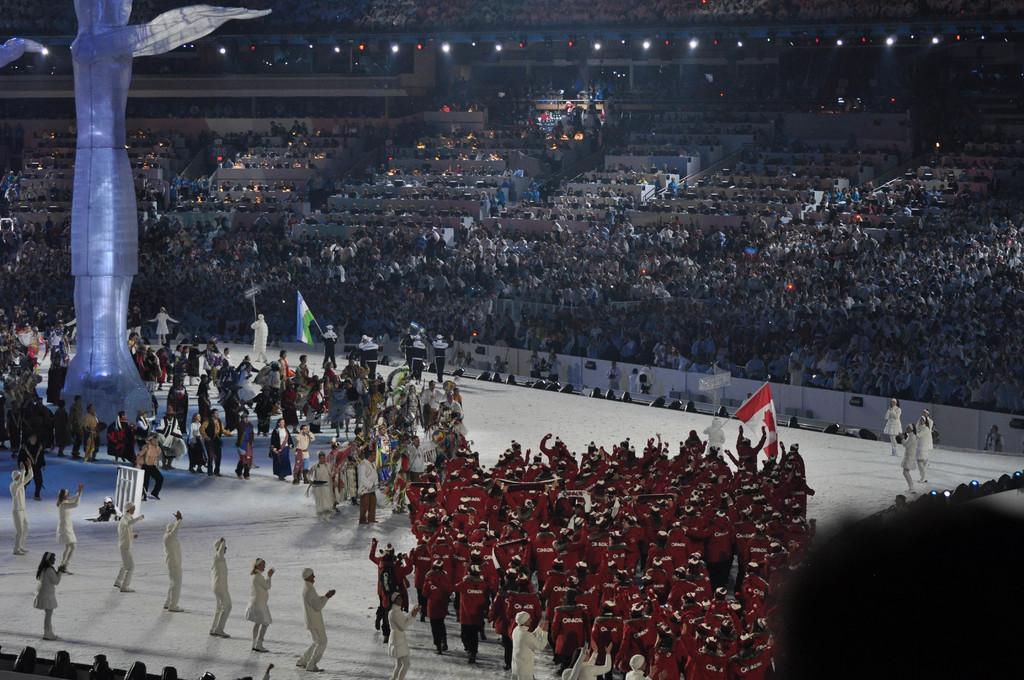Describe this image in one or two sentences. This picture might be taken inside a stadium. In this image, on the right corner, we can see hair of a person. In the middle, we can see group of people standing, we can also see a person holding a flag in the middle. On the left side, we can see a sculpture, group of people. In the background, we can see group of people, chairs and few lights. 